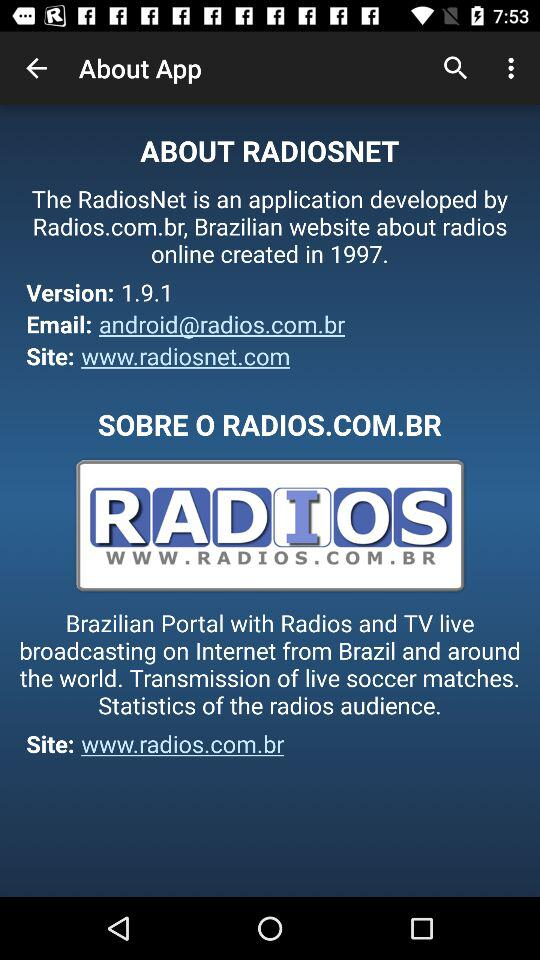What is the email address of "RADIOSNET"? The email address is android@radios.com.br. 